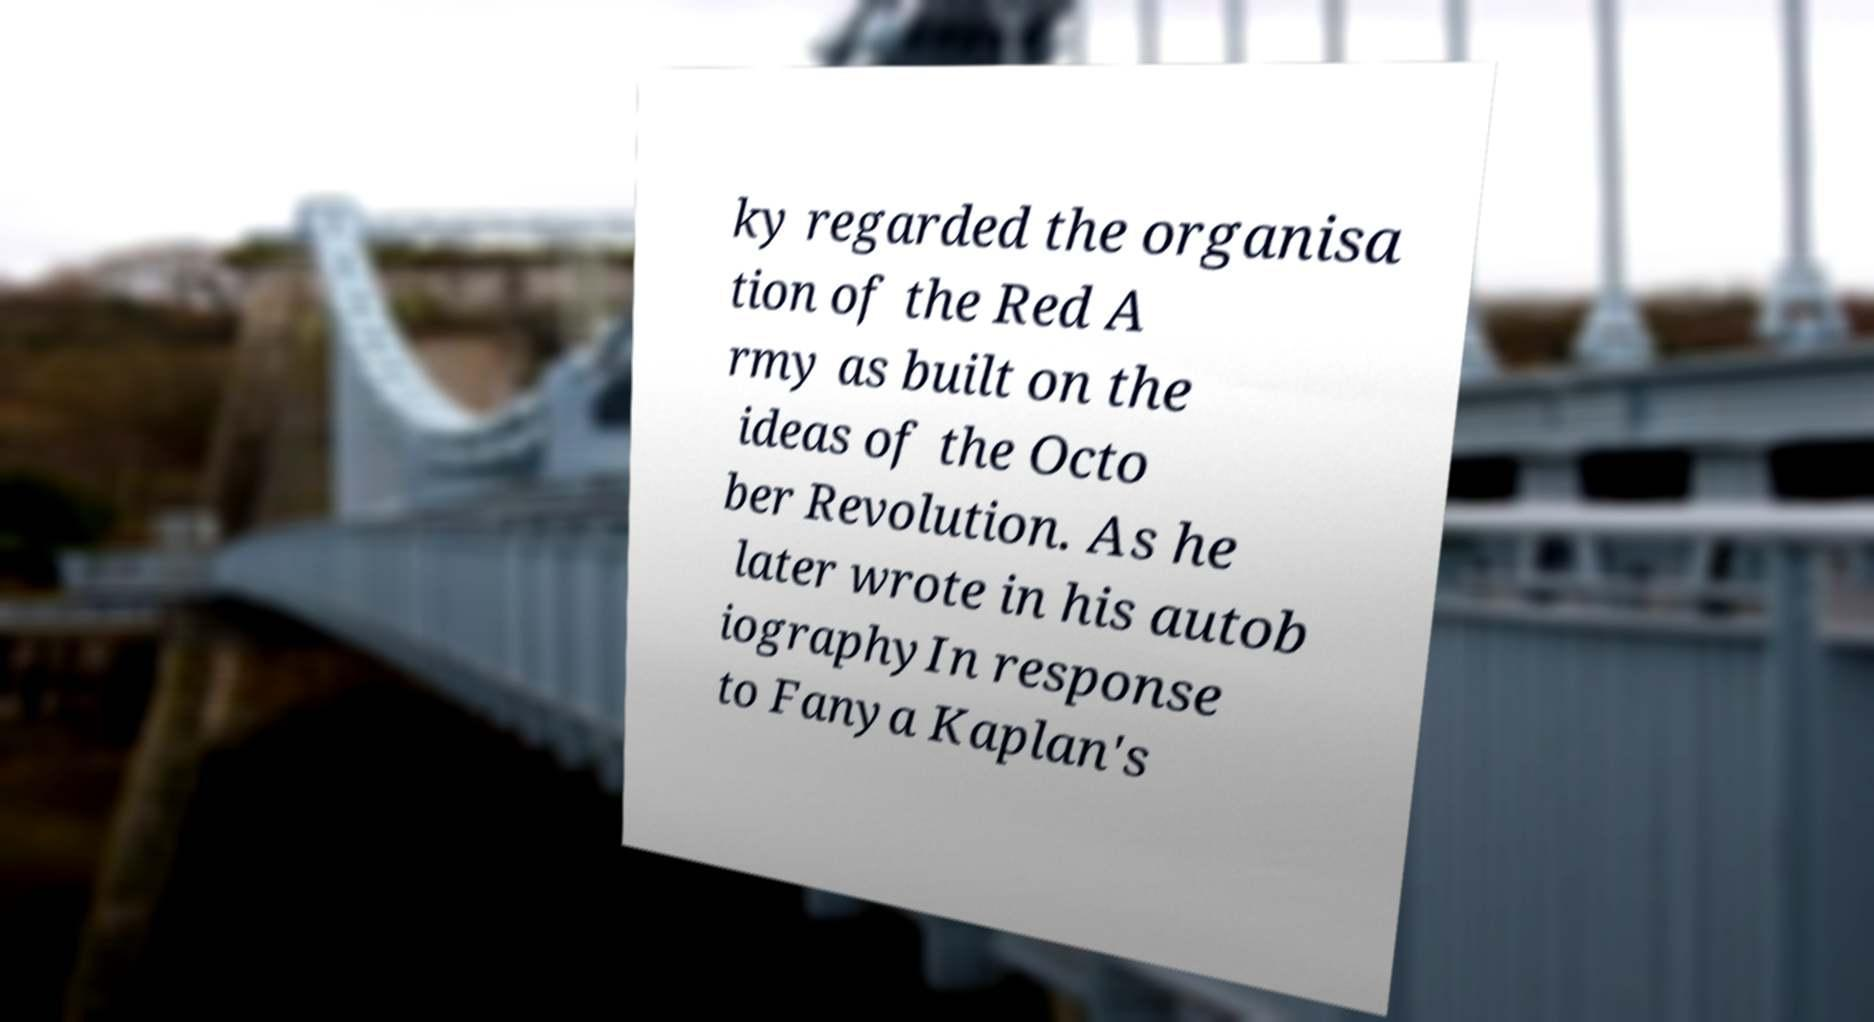Please read and relay the text visible in this image. What does it say? ky regarded the organisa tion of the Red A rmy as built on the ideas of the Octo ber Revolution. As he later wrote in his autob iographyIn response to Fanya Kaplan's 